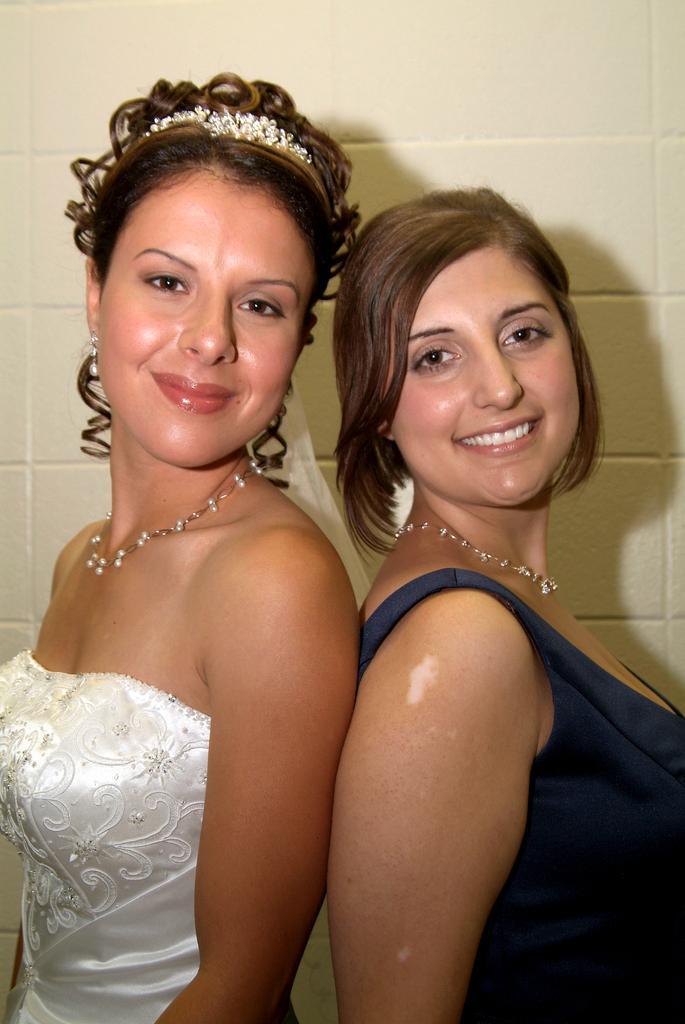How would you summarize this image in a sentence or two? 2 women are standing, this is wall. 